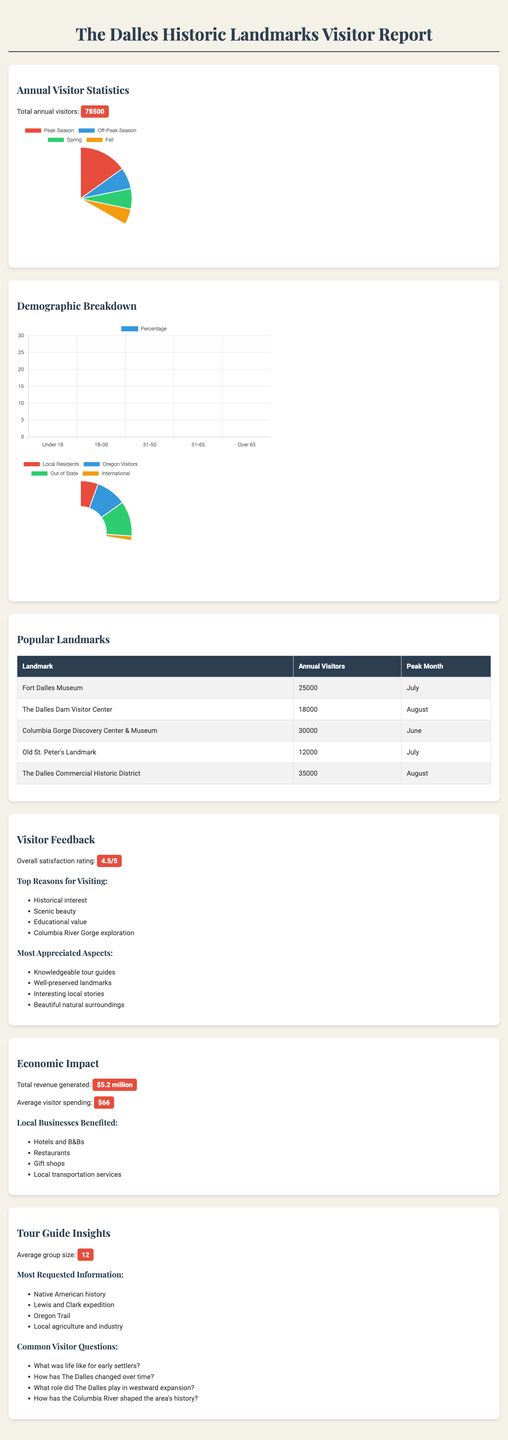What is the total number of annual visitors? The total number of annual visitors is given directly in the document.
Answer: 78500 Which months are categorized as peak season? The peak season months are listed clearly in the document.
Answer: June, July, August What percentage of visitors are local residents? The percentage of local residents is provided in the demographic breakdown section.
Answer: 20 What is the overall satisfaction rating of visitors? The overall satisfaction rating is explicitly mentioned in the feedback section.
Answer: 4.5 Which landmark had the highest number of annual visitors? The document lists annual visitors for each landmark, allowing comparison.
Answer: Columbia Gorge Discovery Center & Museum In which month do the Fort Dalles Museum peak visitors occur? The peak month for visitors at the Fort Dalles Museum is specified in the data.
Answer: July What is the average visitor spending? The average visitor spending is provided in the economic impact section.
Answer: $66 What group composition has the highest percentage of visitors? The group composition data shows different group types with their percentages.
Answer: Families What are the top three reasons for visiting? The document lists the main reasons visitors choose to visit, allowing for easy retrieval.
Answer: Historical interest, Scenic beauty, Educational value 